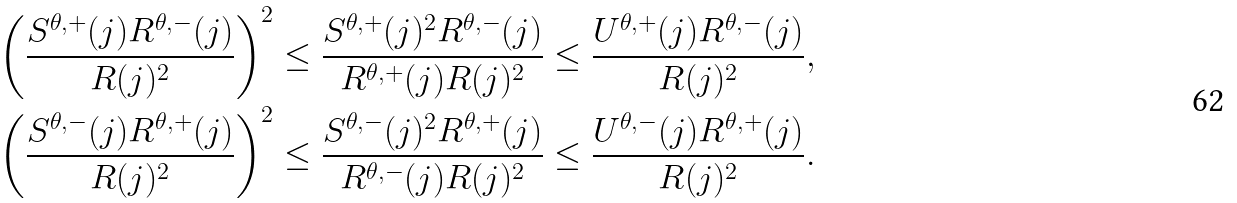<formula> <loc_0><loc_0><loc_500><loc_500>& \left ( \frac { S ^ { \theta , + } ( j ) R ^ { \theta , - } ( j ) } { R ( j ) ^ { 2 } } \right ) ^ { 2 } \leq \frac { S ^ { \theta , + } ( j ) ^ { 2 } R ^ { \theta , - } ( j ) } { R ^ { \theta , + } ( j ) R ( j ) ^ { 2 } } \leq \frac { U ^ { \theta , + } ( j ) R ^ { \theta , - } ( j ) } { R ( j ) ^ { 2 } } , \\ & \left ( \frac { S ^ { \theta , - } ( j ) R ^ { \theta , + } ( j ) } { R ( j ) ^ { 2 } } \right ) ^ { 2 } \leq \frac { S ^ { \theta , - } ( j ) ^ { 2 } R ^ { \theta , + } ( j ) } { R ^ { \theta , - } ( j ) R ( j ) ^ { 2 } } \leq \frac { U ^ { \theta , - } ( j ) R ^ { \theta , + } ( j ) } { R ( j ) ^ { 2 } } .</formula> 